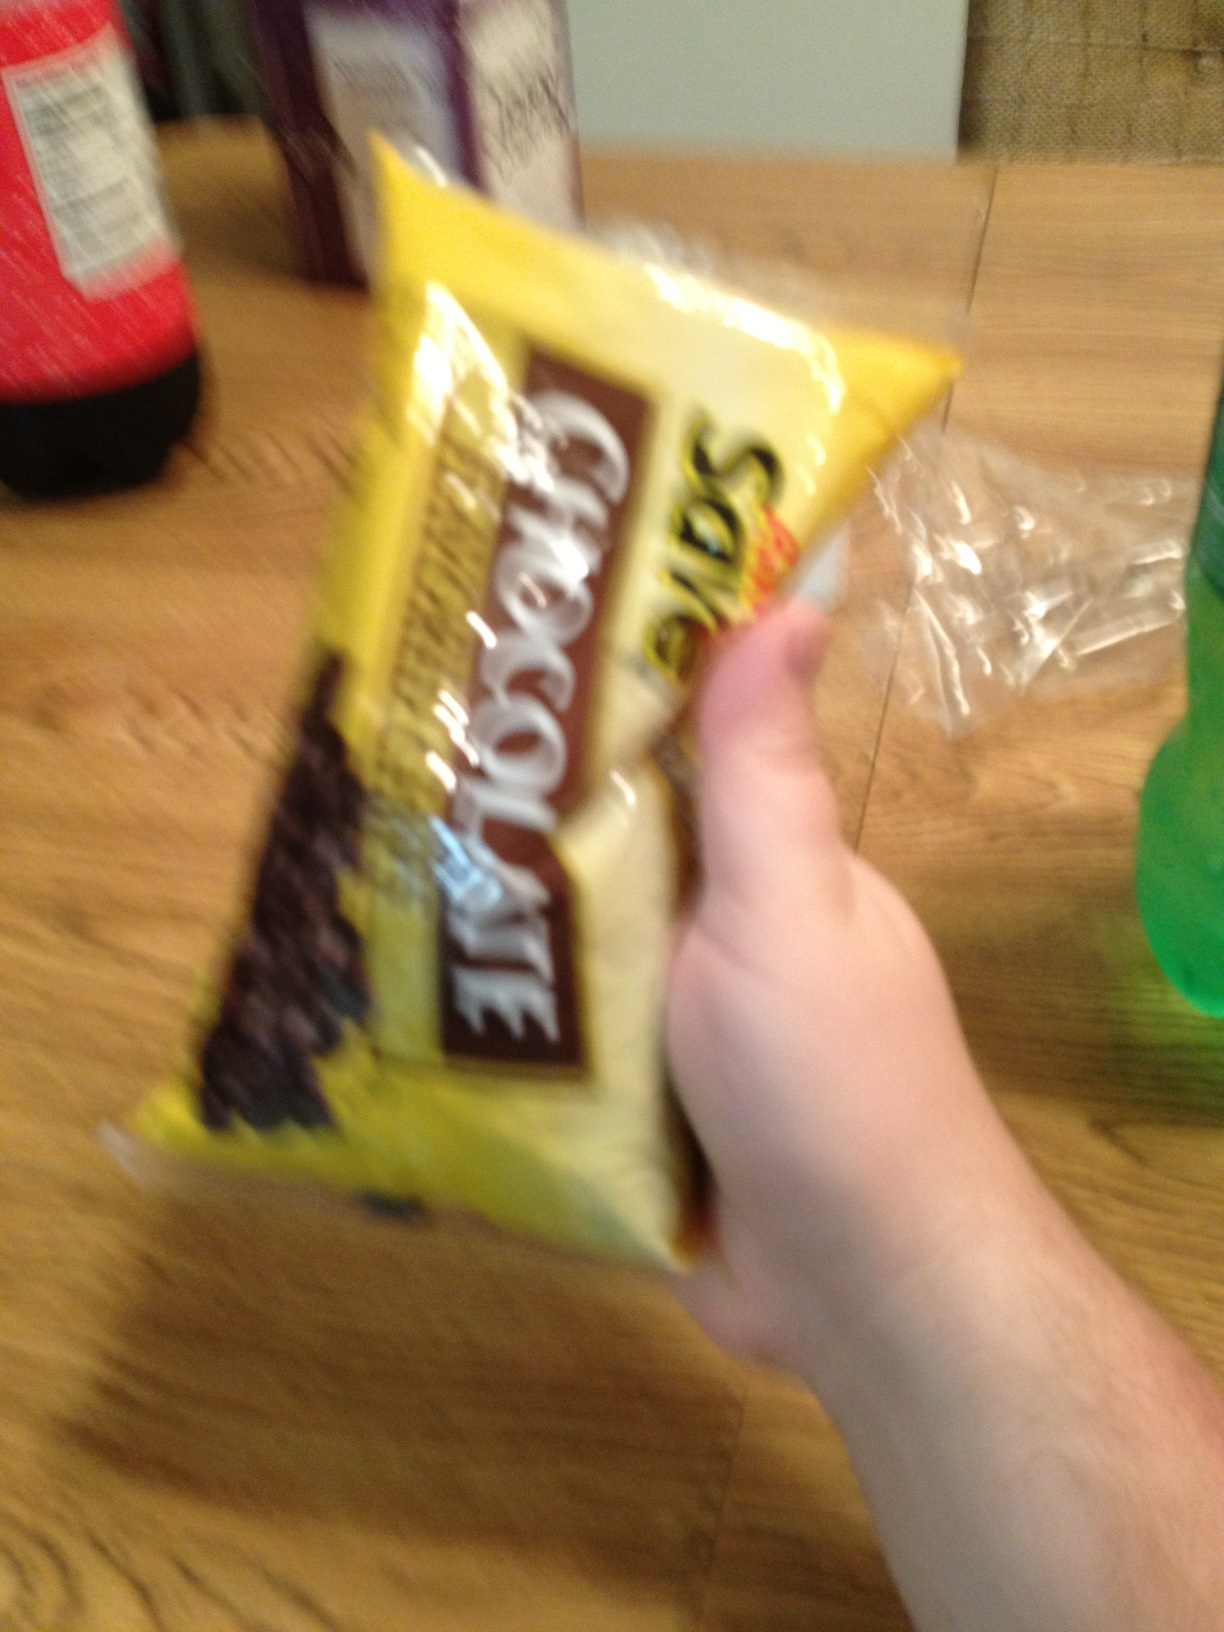What other ingredients would pair well with these chocolate chips for baking? Nuts like walnuts or pecans, various dried fruits such as cranberries or raisins, or spices like cinnamon or nutmeg all make delicious additions to recipes using chocolate chips. 